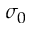<formula> <loc_0><loc_0><loc_500><loc_500>\sigma _ { 0 }</formula> 